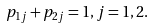Convert formula to latex. <formula><loc_0><loc_0><loc_500><loc_500>p _ { 1 j } + p _ { 2 j } = 1 , j = 1 , 2 .</formula> 